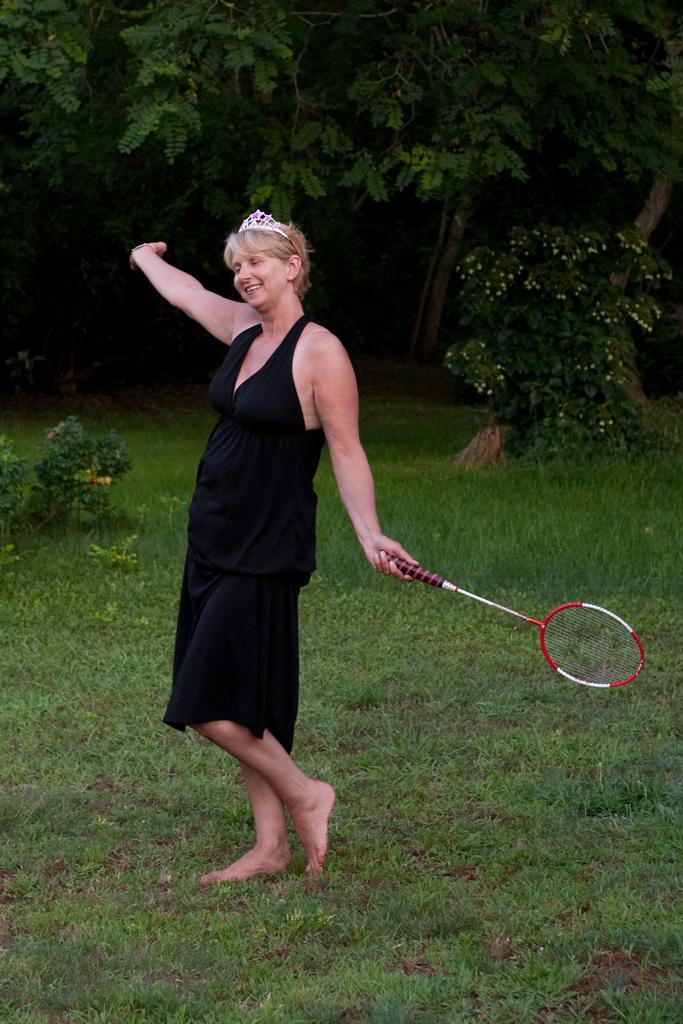Could you give a brief overview of what you see in this image? In this picture there is a woman standing holding a tennis racket and smiling and in the backdrop there are some trees 